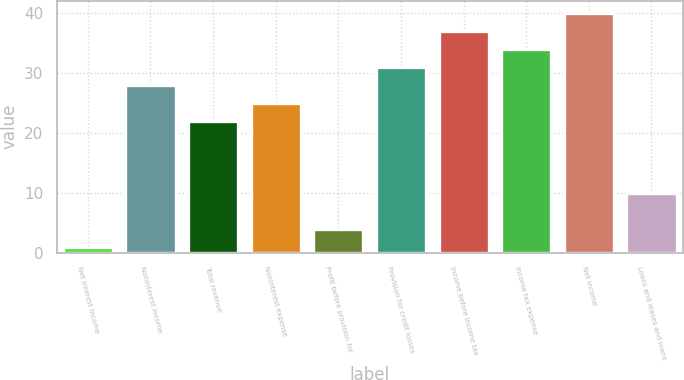Convert chart. <chart><loc_0><loc_0><loc_500><loc_500><bar_chart><fcel>Net interest income<fcel>Noninterest income<fcel>Total revenue<fcel>Noninterest expense<fcel>Profit before provision for<fcel>Provision for credit losses<fcel>Income before income tax<fcel>Income tax expense<fcel>Net income<fcel>Loans and leases and loans<nl><fcel>1<fcel>28<fcel>22<fcel>25<fcel>4<fcel>31<fcel>37<fcel>34<fcel>40<fcel>10<nl></chart> 